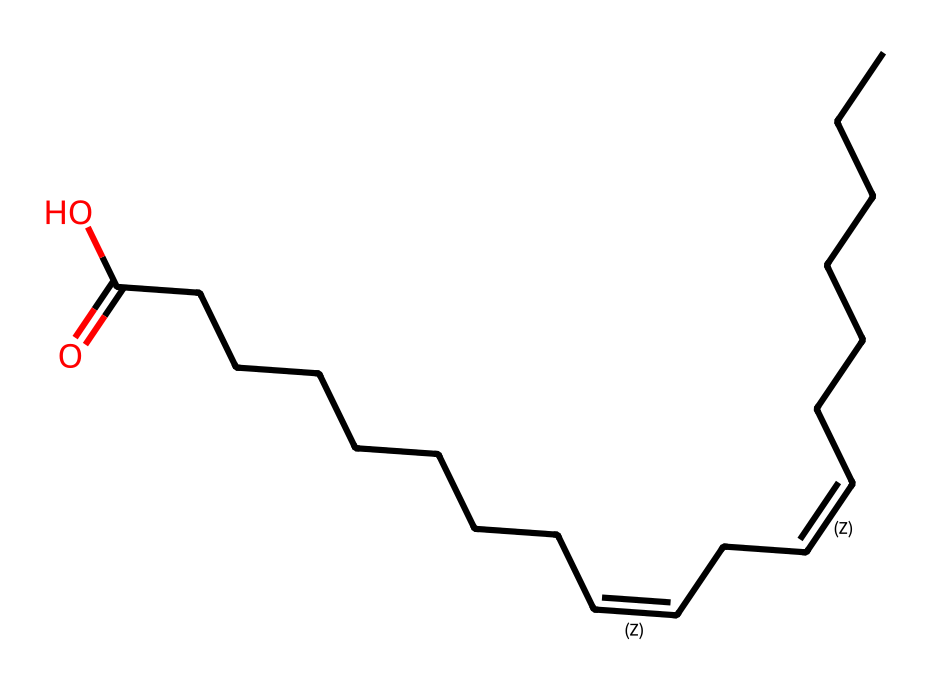What is the number of carbon atoms in linoleic acid? The SMILES representation shows a linear chain of carbon atoms (C) and the structure indicates the presence of various double bonds. Counting each carbon atom from the structure yields a total of 18 carbon atoms.
Answer: 18 What type of bonds are present in linoleic acid? The SMILES notation includes both single bonds (denoted by the absence of a number) and double bonds (denoted by the "=" symbol). In total, there are several single bonds and two double bonds in the structure.
Answer: single and double How many double bonds are present in linoleic acid? From the structure, the double bonds are indicated by the symbols "/C=C\". There are two of these instances in the structure, confirming that linoleic acid has two double bonds.
Answer: 2 What type of isomerism does linoleic acid exhibit? Linoleic acid has geometric isomers: 'cis' and 'trans'. The presence of double bonds allows for these configurations, determined by the arrangement of the hydrogen atoms around the double bonds.
Answer: cis-trans Which part of the chemical structure indicates cis-trans isomerism? The presence of double bonds in the structure allows for different arrangements of substituents. Specifically, the orientation of the hydrogen atoms around each double bond can change between the cis (same side) and trans (opposite side) placement.
Answer: double bonds Why is linoleic acid important for athletes? Linoleic acid is an essential fatty acid that plays a crucial role in cell membrane structure and inflammation regulation. Its importance stems from its function in energy production and recovery, which are essential for athletic performance.
Answer: essential fatty acid 